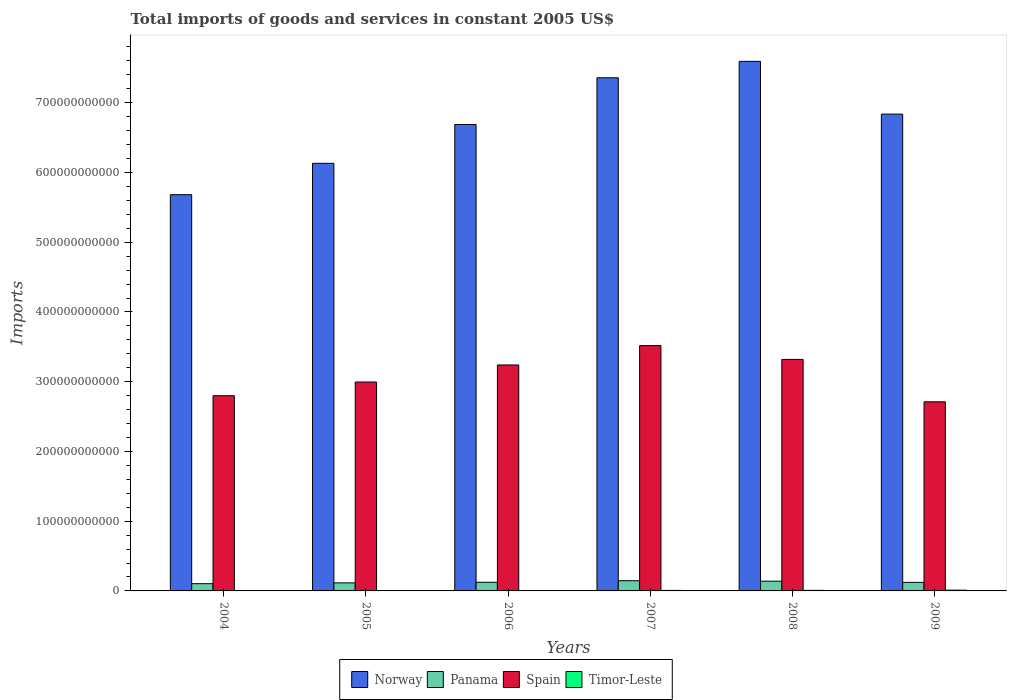How many bars are there on the 4th tick from the right?
Provide a short and direct response. 4. What is the label of the 3rd group of bars from the left?
Your answer should be compact. 2006. In how many cases, is the number of bars for a given year not equal to the number of legend labels?
Keep it short and to the point. 0. What is the total imports of goods and services in Timor-Leste in 2009?
Your answer should be very brief. 1.09e+09. Across all years, what is the maximum total imports of goods and services in Timor-Leste?
Your answer should be very brief. 1.09e+09. Across all years, what is the minimum total imports of goods and services in Norway?
Your response must be concise. 5.68e+11. What is the total total imports of goods and services in Spain in the graph?
Your answer should be very brief. 1.86e+12. What is the difference between the total imports of goods and services in Norway in 2004 and that in 2006?
Your answer should be very brief. -1.01e+11. What is the difference between the total imports of goods and services in Panama in 2006 and the total imports of goods and services in Spain in 2004?
Provide a succinct answer. -2.67e+11. What is the average total imports of goods and services in Timor-Leste per year?
Your answer should be compact. 6.84e+08. In the year 2005, what is the difference between the total imports of goods and services in Panama and total imports of goods and services in Norway?
Keep it short and to the point. -6.02e+11. What is the ratio of the total imports of goods and services in Panama in 2005 to that in 2008?
Your answer should be compact. 0.83. What is the difference between the highest and the second highest total imports of goods and services in Panama?
Your response must be concise. 6.65e+08. What is the difference between the highest and the lowest total imports of goods and services in Norway?
Ensure brevity in your answer.  1.91e+11. Is the sum of the total imports of goods and services in Norway in 2005 and 2008 greater than the maximum total imports of goods and services in Spain across all years?
Your answer should be very brief. Yes. What does the 4th bar from the left in 2006 represents?
Provide a succinct answer. Timor-Leste. What does the 3rd bar from the right in 2009 represents?
Provide a succinct answer. Panama. Are all the bars in the graph horizontal?
Offer a very short reply. No. What is the difference between two consecutive major ticks on the Y-axis?
Your answer should be compact. 1.00e+11. How are the legend labels stacked?
Provide a short and direct response. Horizontal. What is the title of the graph?
Keep it short and to the point. Total imports of goods and services in constant 2005 US$. What is the label or title of the Y-axis?
Offer a very short reply. Imports. What is the Imports in Norway in 2004?
Your answer should be compact. 5.68e+11. What is the Imports in Panama in 2004?
Offer a very short reply. 1.04e+1. What is the Imports of Spain in 2004?
Give a very brief answer. 2.80e+11. What is the Imports of Timor-Leste in 2004?
Offer a very short reply. 5.98e+08. What is the Imports of Norway in 2005?
Provide a short and direct response. 6.13e+11. What is the Imports of Panama in 2005?
Keep it short and to the point. 1.15e+1. What is the Imports of Spain in 2005?
Make the answer very short. 3.00e+11. What is the Imports of Timor-Leste in 2005?
Your answer should be compact. 3.99e+08. What is the Imports of Norway in 2006?
Offer a very short reply. 6.69e+11. What is the Imports in Panama in 2006?
Your response must be concise. 1.24e+1. What is the Imports in Spain in 2006?
Ensure brevity in your answer.  3.24e+11. What is the Imports in Timor-Leste in 2006?
Offer a terse response. 4.84e+08. What is the Imports of Norway in 2007?
Your response must be concise. 7.36e+11. What is the Imports of Panama in 2007?
Your answer should be compact. 1.46e+1. What is the Imports of Spain in 2007?
Offer a terse response. 3.52e+11. What is the Imports in Timor-Leste in 2007?
Provide a succinct answer. 7.21e+08. What is the Imports in Norway in 2008?
Your answer should be very brief. 7.59e+11. What is the Imports in Panama in 2008?
Offer a terse response. 1.40e+1. What is the Imports of Spain in 2008?
Offer a terse response. 3.32e+11. What is the Imports in Timor-Leste in 2008?
Your response must be concise. 8.13e+08. What is the Imports of Norway in 2009?
Your response must be concise. 6.84e+11. What is the Imports in Panama in 2009?
Ensure brevity in your answer.  1.23e+1. What is the Imports of Spain in 2009?
Keep it short and to the point. 2.71e+11. What is the Imports of Timor-Leste in 2009?
Keep it short and to the point. 1.09e+09. Across all years, what is the maximum Imports of Norway?
Provide a short and direct response. 7.59e+11. Across all years, what is the maximum Imports of Panama?
Your answer should be compact. 1.46e+1. Across all years, what is the maximum Imports of Spain?
Offer a terse response. 3.52e+11. Across all years, what is the maximum Imports in Timor-Leste?
Give a very brief answer. 1.09e+09. Across all years, what is the minimum Imports in Norway?
Keep it short and to the point. 5.68e+11. Across all years, what is the minimum Imports in Panama?
Give a very brief answer. 1.04e+1. Across all years, what is the minimum Imports in Spain?
Give a very brief answer. 2.71e+11. Across all years, what is the minimum Imports of Timor-Leste?
Offer a terse response. 3.99e+08. What is the total Imports of Norway in the graph?
Offer a terse response. 4.03e+12. What is the total Imports of Panama in the graph?
Offer a terse response. 7.52e+1. What is the total Imports of Spain in the graph?
Your answer should be very brief. 1.86e+12. What is the total Imports in Timor-Leste in the graph?
Your answer should be compact. 4.10e+09. What is the difference between the Imports in Norway in 2004 and that in 2005?
Offer a very short reply. -4.50e+1. What is the difference between the Imports of Panama in 2004 and that in 2005?
Ensure brevity in your answer.  -1.16e+09. What is the difference between the Imports of Spain in 2004 and that in 2005?
Make the answer very short. -1.97e+1. What is the difference between the Imports in Timor-Leste in 2004 and that in 2005?
Provide a succinct answer. 1.99e+08. What is the difference between the Imports of Norway in 2004 and that in 2006?
Keep it short and to the point. -1.01e+11. What is the difference between the Imports in Panama in 2004 and that in 2006?
Offer a terse response. -2.02e+09. What is the difference between the Imports in Spain in 2004 and that in 2006?
Keep it short and to the point. -4.41e+1. What is the difference between the Imports of Timor-Leste in 2004 and that in 2006?
Provide a short and direct response. 1.14e+08. What is the difference between the Imports of Norway in 2004 and that in 2007?
Provide a succinct answer. -1.68e+11. What is the difference between the Imports in Panama in 2004 and that in 2007?
Your answer should be very brief. -4.25e+09. What is the difference between the Imports in Spain in 2004 and that in 2007?
Your answer should be compact. -7.19e+1. What is the difference between the Imports of Timor-Leste in 2004 and that in 2007?
Your response must be concise. -1.23e+08. What is the difference between the Imports of Norway in 2004 and that in 2008?
Provide a short and direct response. -1.91e+11. What is the difference between the Imports of Panama in 2004 and that in 2008?
Provide a succinct answer. -3.59e+09. What is the difference between the Imports in Spain in 2004 and that in 2008?
Provide a short and direct response. -5.21e+1. What is the difference between the Imports of Timor-Leste in 2004 and that in 2008?
Keep it short and to the point. -2.15e+08. What is the difference between the Imports in Norway in 2004 and that in 2009?
Your answer should be compact. -1.16e+11. What is the difference between the Imports of Panama in 2004 and that in 2009?
Offer a very short reply. -1.88e+09. What is the difference between the Imports in Spain in 2004 and that in 2009?
Your answer should be very brief. 8.70e+09. What is the difference between the Imports in Timor-Leste in 2004 and that in 2009?
Your answer should be very brief. -4.91e+08. What is the difference between the Imports of Norway in 2005 and that in 2006?
Ensure brevity in your answer.  -5.56e+1. What is the difference between the Imports in Panama in 2005 and that in 2006?
Provide a short and direct response. -8.57e+08. What is the difference between the Imports in Spain in 2005 and that in 2006?
Give a very brief answer. -2.45e+1. What is the difference between the Imports of Timor-Leste in 2005 and that in 2006?
Give a very brief answer. -8.50e+07. What is the difference between the Imports in Norway in 2005 and that in 2007?
Your answer should be very brief. -1.23e+11. What is the difference between the Imports in Panama in 2005 and that in 2007?
Provide a short and direct response. -3.09e+09. What is the difference between the Imports of Spain in 2005 and that in 2007?
Your response must be concise. -5.22e+1. What is the difference between the Imports of Timor-Leste in 2005 and that in 2007?
Offer a very short reply. -3.22e+08. What is the difference between the Imports of Norway in 2005 and that in 2008?
Keep it short and to the point. -1.46e+11. What is the difference between the Imports of Panama in 2005 and that in 2008?
Provide a short and direct response. -2.43e+09. What is the difference between the Imports in Spain in 2005 and that in 2008?
Your response must be concise. -3.24e+1. What is the difference between the Imports in Timor-Leste in 2005 and that in 2008?
Provide a short and direct response. -4.14e+08. What is the difference between the Imports in Norway in 2005 and that in 2009?
Offer a terse response. -7.06e+1. What is the difference between the Imports of Panama in 2005 and that in 2009?
Offer a very short reply. -7.20e+08. What is the difference between the Imports of Spain in 2005 and that in 2009?
Your answer should be compact. 2.84e+1. What is the difference between the Imports in Timor-Leste in 2005 and that in 2009?
Your answer should be very brief. -6.90e+08. What is the difference between the Imports in Norway in 2006 and that in 2007?
Keep it short and to the point. -6.70e+1. What is the difference between the Imports in Panama in 2006 and that in 2007?
Your answer should be compact. -2.24e+09. What is the difference between the Imports of Spain in 2006 and that in 2007?
Offer a terse response. -2.77e+1. What is the difference between the Imports in Timor-Leste in 2006 and that in 2007?
Give a very brief answer. -2.37e+08. What is the difference between the Imports in Norway in 2006 and that in 2008?
Provide a short and direct response. -9.06e+1. What is the difference between the Imports in Panama in 2006 and that in 2008?
Your response must be concise. -1.57e+09. What is the difference between the Imports of Spain in 2006 and that in 2008?
Provide a short and direct response. -7.98e+09. What is the difference between the Imports in Timor-Leste in 2006 and that in 2008?
Your response must be concise. -3.29e+08. What is the difference between the Imports of Norway in 2006 and that in 2009?
Your response must be concise. -1.49e+1. What is the difference between the Imports in Panama in 2006 and that in 2009?
Offer a very short reply. 1.37e+08. What is the difference between the Imports in Spain in 2006 and that in 2009?
Offer a terse response. 5.28e+1. What is the difference between the Imports in Timor-Leste in 2006 and that in 2009?
Provide a short and direct response. -6.05e+08. What is the difference between the Imports of Norway in 2007 and that in 2008?
Your answer should be very brief. -2.36e+1. What is the difference between the Imports in Panama in 2007 and that in 2008?
Offer a terse response. 6.65e+08. What is the difference between the Imports in Spain in 2007 and that in 2008?
Offer a terse response. 1.98e+1. What is the difference between the Imports in Timor-Leste in 2007 and that in 2008?
Keep it short and to the point. -9.20e+07. What is the difference between the Imports of Norway in 2007 and that in 2009?
Your answer should be very brief. 5.21e+1. What is the difference between the Imports in Panama in 2007 and that in 2009?
Make the answer very short. 2.37e+09. What is the difference between the Imports of Spain in 2007 and that in 2009?
Your answer should be very brief. 8.06e+1. What is the difference between the Imports in Timor-Leste in 2007 and that in 2009?
Make the answer very short. -3.68e+08. What is the difference between the Imports of Norway in 2008 and that in 2009?
Your response must be concise. 7.56e+1. What is the difference between the Imports of Panama in 2008 and that in 2009?
Keep it short and to the point. 1.71e+09. What is the difference between the Imports of Spain in 2008 and that in 2009?
Make the answer very short. 6.08e+1. What is the difference between the Imports of Timor-Leste in 2008 and that in 2009?
Provide a succinct answer. -2.76e+08. What is the difference between the Imports of Norway in 2004 and the Imports of Panama in 2005?
Keep it short and to the point. 5.57e+11. What is the difference between the Imports in Norway in 2004 and the Imports in Spain in 2005?
Provide a succinct answer. 2.69e+11. What is the difference between the Imports of Norway in 2004 and the Imports of Timor-Leste in 2005?
Keep it short and to the point. 5.68e+11. What is the difference between the Imports of Panama in 2004 and the Imports of Spain in 2005?
Your answer should be very brief. -2.89e+11. What is the difference between the Imports of Panama in 2004 and the Imports of Timor-Leste in 2005?
Ensure brevity in your answer.  9.98e+09. What is the difference between the Imports in Spain in 2004 and the Imports in Timor-Leste in 2005?
Your response must be concise. 2.79e+11. What is the difference between the Imports in Norway in 2004 and the Imports in Panama in 2006?
Keep it short and to the point. 5.56e+11. What is the difference between the Imports in Norway in 2004 and the Imports in Spain in 2006?
Offer a terse response. 2.44e+11. What is the difference between the Imports in Norway in 2004 and the Imports in Timor-Leste in 2006?
Provide a short and direct response. 5.68e+11. What is the difference between the Imports in Panama in 2004 and the Imports in Spain in 2006?
Provide a succinct answer. -3.14e+11. What is the difference between the Imports of Panama in 2004 and the Imports of Timor-Leste in 2006?
Make the answer very short. 9.90e+09. What is the difference between the Imports in Spain in 2004 and the Imports in Timor-Leste in 2006?
Provide a succinct answer. 2.79e+11. What is the difference between the Imports in Norway in 2004 and the Imports in Panama in 2007?
Your answer should be compact. 5.54e+11. What is the difference between the Imports of Norway in 2004 and the Imports of Spain in 2007?
Give a very brief answer. 2.16e+11. What is the difference between the Imports in Norway in 2004 and the Imports in Timor-Leste in 2007?
Your answer should be very brief. 5.67e+11. What is the difference between the Imports in Panama in 2004 and the Imports in Spain in 2007?
Your answer should be compact. -3.41e+11. What is the difference between the Imports of Panama in 2004 and the Imports of Timor-Leste in 2007?
Ensure brevity in your answer.  9.66e+09. What is the difference between the Imports of Spain in 2004 and the Imports of Timor-Leste in 2007?
Offer a terse response. 2.79e+11. What is the difference between the Imports of Norway in 2004 and the Imports of Panama in 2008?
Ensure brevity in your answer.  5.54e+11. What is the difference between the Imports in Norway in 2004 and the Imports in Spain in 2008?
Offer a terse response. 2.36e+11. What is the difference between the Imports of Norway in 2004 and the Imports of Timor-Leste in 2008?
Provide a short and direct response. 5.67e+11. What is the difference between the Imports in Panama in 2004 and the Imports in Spain in 2008?
Keep it short and to the point. -3.22e+11. What is the difference between the Imports in Panama in 2004 and the Imports in Timor-Leste in 2008?
Your answer should be very brief. 9.57e+09. What is the difference between the Imports in Spain in 2004 and the Imports in Timor-Leste in 2008?
Your response must be concise. 2.79e+11. What is the difference between the Imports of Norway in 2004 and the Imports of Panama in 2009?
Your answer should be very brief. 5.56e+11. What is the difference between the Imports in Norway in 2004 and the Imports in Spain in 2009?
Give a very brief answer. 2.97e+11. What is the difference between the Imports in Norway in 2004 and the Imports in Timor-Leste in 2009?
Your answer should be very brief. 5.67e+11. What is the difference between the Imports in Panama in 2004 and the Imports in Spain in 2009?
Offer a terse response. -2.61e+11. What is the difference between the Imports of Panama in 2004 and the Imports of Timor-Leste in 2009?
Offer a terse response. 9.29e+09. What is the difference between the Imports of Spain in 2004 and the Imports of Timor-Leste in 2009?
Give a very brief answer. 2.79e+11. What is the difference between the Imports of Norway in 2005 and the Imports of Panama in 2006?
Ensure brevity in your answer.  6.01e+11. What is the difference between the Imports in Norway in 2005 and the Imports in Spain in 2006?
Ensure brevity in your answer.  2.89e+11. What is the difference between the Imports of Norway in 2005 and the Imports of Timor-Leste in 2006?
Your answer should be very brief. 6.13e+11. What is the difference between the Imports in Panama in 2005 and the Imports in Spain in 2006?
Make the answer very short. -3.12e+11. What is the difference between the Imports of Panama in 2005 and the Imports of Timor-Leste in 2006?
Give a very brief answer. 1.11e+1. What is the difference between the Imports of Spain in 2005 and the Imports of Timor-Leste in 2006?
Provide a short and direct response. 2.99e+11. What is the difference between the Imports in Norway in 2005 and the Imports in Panama in 2007?
Your answer should be very brief. 5.98e+11. What is the difference between the Imports of Norway in 2005 and the Imports of Spain in 2007?
Provide a succinct answer. 2.61e+11. What is the difference between the Imports in Norway in 2005 and the Imports in Timor-Leste in 2007?
Make the answer very short. 6.12e+11. What is the difference between the Imports in Panama in 2005 and the Imports in Spain in 2007?
Offer a terse response. -3.40e+11. What is the difference between the Imports in Panama in 2005 and the Imports in Timor-Leste in 2007?
Keep it short and to the point. 1.08e+1. What is the difference between the Imports of Spain in 2005 and the Imports of Timor-Leste in 2007?
Provide a short and direct response. 2.99e+11. What is the difference between the Imports in Norway in 2005 and the Imports in Panama in 2008?
Ensure brevity in your answer.  5.99e+11. What is the difference between the Imports in Norway in 2005 and the Imports in Spain in 2008?
Ensure brevity in your answer.  2.81e+11. What is the difference between the Imports in Norway in 2005 and the Imports in Timor-Leste in 2008?
Provide a succinct answer. 6.12e+11. What is the difference between the Imports of Panama in 2005 and the Imports of Spain in 2008?
Provide a short and direct response. -3.20e+11. What is the difference between the Imports in Panama in 2005 and the Imports in Timor-Leste in 2008?
Provide a succinct answer. 1.07e+1. What is the difference between the Imports of Spain in 2005 and the Imports of Timor-Leste in 2008?
Provide a short and direct response. 2.99e+11. What is the difference between the Imports in Norway in 2005 and the Imports in Panama in 2009?
Offer a very short reply. 6.01e+11. What is the difference between the Imports of Norway in 2005 and the Imports of Spain in 2009?
Provide a short and direct response. 3.42e+11. What is the difference between the Imports of Norway in 2005 and the Imports of Timor-Leste in 2009?
Ensure brevity in your answer.  6.12e+11. What is the difference between the Imports in Panama in 2005 and the Imports in Spain in 2009?
Offer a very short reply. -2.60e+11. What is the difference between the Imports of Panama in 2005 and the Imports of Timor-Leste in 2009?
Make the answer very short. 1.05e+1. What is the difference between the Imports of Spain in 2005 and the Imports of Timor-Leste in 2009?
Offer a very short reply. 2.98e+11. What is the difference between the Imports in Norway in 2006 and the Imports in Panama in 2007?
Your answer should be compact. 6.54e+11. What is the difference between the Imports in Norway in 2006 and the Imports in Spain in 2007?
Your response must be concise. 3.17e+11. What is the difference between the Imports in Norway in 2006 and the Imports in Timor-Leste in 2007?
Your answer should be compact. 6.68e+11. What is the difference between the Imports of Panama in 2006 and the Imports of Spain in 2007?
Your answer should be very brief. -3.39e+11. What is the difference between the Imports of Panama in 2006 and the Imports of Timor-Leste in 2007?
Your response must be concise. 1.17e+1. What is the difference between the Imports of Spain in 2006 and the Imports of Timor-Leste in 2007?
Provide a succinct answer. 3.23e+11. What is the difference between the Imports of Norway in 2006 and the Imports of Panama in 2008?
Offer a terse response. 6.55e+11. What is the difference between the Imports in Norway in 2006 and the Imports in Spain in 2008?
Give a very brief answer. 3.37e+11. What is the difference between the Imports in Norway in 2006 and the Imports in Timor-Leste in 2008?
Offer a very short reply. 6.68e+11. What is the difference between the Imports of Panama in 2006 and the Imports of Spain in 2008?
Offer a very short reply. -3.20e+11. What is the difference between the Imports of Panama in 2006 and the Imports of Timor-Leste in 2008?
Your response must be concise. 1.16e+1. What is the difference between the Imports of Spain in 2006 and the Imports of Timor-Leste in 2008?
Your response must be concise. 3.23e+11. What is the difference between the Imports in Norway in 2006 and the Imports in Panama in 2009?
Give a very brief answer. 6.57e+11. What is the difference between the Imports of Norway in 2006 and the Imports of Spain in 2009?
Keep it short and to the point. 3.98e+11. What is the difference between the Imports of Norway in 2006 and the Imports of Timor-Leste in 2009?
Your response must be concise. 6.68e+11. What is the difference between the Imports of Panama in 2006 and the Imports of Spain in 2009?
Your answer should be compact. -2.59e+11. What is the difference between the Imports of Panama in 2006 and the Imports of Timor-Leste in 2009?
Make the answer very short. 1.13e+1. What is the difference between the Imports of Spain in 2006 and the Imports of Timor-Leste in 2009?
Make the answer very short. 3.23e+11. What is the difference between the Imports in Norway in 2007 and the Imports in Panama in 2008?
Provide a short and direct response. 7.22e+11. What is the difference between the Imports of Norway in 2007 and the Imports of Spain in 2008?
Provide a short and direct response. 4.04e+11. What is the difference between the Imports in Norway in 2007 and the Imports in Timor-Leste in 2008?
Offer a terse response. 7.35e+11. What is the difference between the Imports in Panama in 2007 and the Imports in Spain in 2008?
Your answer should be compact. -3.17e+11. What is the difference between the Imports of Panama in 2007 and the Imports of Timor-Leste in 2008?
Offer a very short reply. 1.38e+1. What is the difference between the Imports of Spain in 2007 and the Imports of Timor-Leste in 2008?
Provide a succinct answer. 3.51e+11. What is the difference between the Imports in Norway in 2007 and the Imports in Panama in 2009?
Ensure brevity in your answer.  7.24e+11. What is the difference between the Imports of Norway in 2007 and the Imports of Spain in 2009?
Offer a very short reply. 4.65e+11. What is the difference between the Imports in Norway in 2007 and the Imports in Timor-Leste in 2009?
Ensure brevity in your answer.  7.35e+11. What is the difference between the Imports in Panama in 2007 and the Imports in Spain in 2009?
Your answer should be compact. -2.57e+11. What is the difference between the Imports of Panama in 2007 and the Imports of Timor-Leste in 2009?
Keep it short and to the point. 1.35e+1. What is the difference between the Imports in Spain in 2007 and the Imports in Timor-Leste in 2009?
Offer a very short reply. 3.51e+11. What is the difference between the Imports in Norway in 2008 and the Imports in Panama in 2009?
Offer a terse response. 7.47e+11. What is the difference between the Imports of Norway in 2008 and the Imports of Spain in 2009?
Ensure brevity in your answer.  4.88e+11. What is the difference between the Imports in Norway in 2008 and the Imports in Timor-Leste in 2009?
Offer a very short reply. 7.58e+11. What is the difference between the Imports of Panama in 2008 and the Imports of Spain in 2009?
Give a very brief answer. -2.57e+11. What is the difference between the Imports in Panama in 2008 and the Imports in Timor-Leste in 2009?
Give a very brief answer. 1.29e+1. What is the difference between the Imports in Spain in 2008 and the Imports in Timor-Leste in 2009?
Your response must be concise. 3.31e+11. What is the average Imports in Norway per year?
Make the answer very short. 6.71e+11. What is the average Imports of Panama per year?
Keep it short and to the point. 1.25e+1. What is the average Imports in Spain per year?
Make the answer very short. 3.10e+11. What is the average Imports in Timor-Leste per year?
Offer a terse response. 6.84e+08. In the year 2004, what is the difference between the Imports in Norway and Imports in Panama?
Ensure brevity in your answer.  5.58e+11. In the year 2004, what is the difference between the Imports in Norway and Imports in Spain?
Your answer should be compact. 2.88e+11. In the year 2004, what is the difference between the Imports in Norway and Imports in Timor-Leste?
Make the answer very short. 5.68e+11. In the year 2004, what is the difference between the Imports in Panama and Imports in Spain?
Provide a short and direct response. -2.69e+11. In the year 2004, what is the difference between the Imports in Panama and Imports in Timor-Leste?
Offer a very short reply. 9.78e+09. In the year 2004, what is the difference between the Imports of Spain and Imports of Timor-Leste?
Offer a very short reply. 2.79e+11. In the year 2005, what is the difference between the Imports of Norway and Imports of Panama?
Give a very brief answer. 6.02e+11. In the year 2005, what is the difference between the Imports of Norway and Imports of Spain?
Provide a short and direct response. 3.14e+11. In the year 2005, what is the difference between the Imports in Norway and Imports in Timor-Leste?
Make the answer very short. 6.13e+11. In the year 2005, what is the difference between the Imports in Panama and Imports in Spain?
Offer a very short reply. -2.88e+11. In the year 2005, what is the difference between the Imports of Panama and Imports of Timor-Leste?
Provide a short and direct response. 1.11e+1. In the year 2005, what is the difference between the Imports of Spain and Imports of Timor-Leste?
Keep it short and to the point. 2.99e+11. In the year 2006, what is the difference between the Imports of Norway and Imports of Panama?
Make the answer very short. 6.56e+11. In the year 2006, what is the difference between the Imports in Norway and Imports in Spain?
Offer a terse response. 3.45e+11. In the year 2006, what is the difference between the Imports of Norway and Imports of Timor-Leste?
Your answer should be compact. 6.68e+11. In the year 2006, what is the difference between the Imports in Panama and Imports in Spain?
Your answer should be compact. -3.12e+11. In the year 2006, what is the difference between the Imports in Panama and Imports in Timor-Leste?
Keep it short and to the point. 1.19e+1. In the year 2006, what is the difference between the Imports of Spain and Imports of Timor-Leste?
Offer a very short reply. 3.24e+11. In the year 2007, what is the difference between the Imports of Norway and Imports of Panama?
Offer a terse response. 7.21e+11. In the year 2007, what is the difference between the Imports of Norway and Imports of Spain?
Provide a succinct answer. 3.84e+11. In the year 2007, what is the difference between the Imports in Norway and Imports in Timor-Leste?
Keep it short and to the point. 7.35e+11. In the year 2007, what is the difference between the Imports of Panama and Imports of Spain?
Give a very brief answer. -3.37e+11. In the year 2007, what is the difference between the Imports in Panama and Imports in Timor-Leste?
Provide a short and direct response. 1.39e+1. In the year 2007, what is the difference between the Imports in Spain and Imports in Timor-Leste?
Ensure brevity in your answer.  3.51e+11. In the year 2008, what is the difference between the Imports of Norway and Imports of Panama?
Ensure brevity in your answer.  7.45e+11. In the year 2008, what is the difference between the Imports in Norway and Imports in Spain?
Give a very brief answer. 4.27e+11. In the year 2008, what is the difference between the Imports in Norway and Imports in Timor-Leste?
Provide a succinct answer. 7.59e+11. In the year 2008, what is the difference between the Imports in Panama and Imports in Spain?
Your answer should be very brief. -3.18e+11. In the year 2008, what is the difference between the Imports in Panama and Imports in Timor-Leste?
Give a very brief answer. 1.32e+1. In the year 2008, what is the difference between the Imports of Spain and Imports of Timor-Leste?
Your answer should be very brief. 3.31e+11. In the year 2009, what is the difference between the Imports of Norway and Imports of Panama?
Provide a succinct answer. 6.71e+11. In the year 2009, what is the difference between the Imports in Norway and Imports in Spain?
Give a very brief answer. 4.13e+11. In the year 2009, what is the difference between the Imports in Norway and Imports in Timor-Leste?
Provide a short and direct response. 6.83e+11. In the year 2009, what is the difference between the Imports of Panama and Imports of Spain?
Your answer should be very brief. -2.59e+11. In the year 2009, what is the difference between the Imports of Panama and Imports of Timor-Leste?
Offer a terse response. 1.12e+1. In the year 2009, what is the difference between the Imports in Spain and Imports in Timor-Leste?
Make the answer very short. 2.70e+11. What is the ratio of the Imports in Norway in 2004 to that in 2005?
Offer a terse response. 0.93. What is the ratio of the Imports of Panama in 2004 to that in 2005?
Offer a terse response. 0.9. What is the ratio of the Imports in Spain in 2004 to that in 2005?
Your response must be concise. 0.93. What is the ratio of the Imports of Timor-Leste in 2004 to that in 2005?
Give a very brief answer. 1.5. What is the ratio of the Imports in Norway in 2004 to that in 2006?
Your answer should be very brief. 0.85. What is the ratio of the Imports in Panama in 2004 to that in 2006?
Your answer should be very brief. 0.84. What is the ratio of the Imports of Spain in 2004 to that in 2006?
Offer a very short reply. 0.86. What is the ratio of the Imports of Timor-Leste in 2004 to that in 2006?
Your response must be concise. 1.24. What is the ratio of the Imports of Norway in 2004 to that in 2007?
Your answer should be compact. 0.77. What is the ratio of the Imports in Panama in 2004 to that in 2007?
Your answer should be compact. 0.71. What is the ratio of the Imports of Spain in 2004 to that in 2007?
Offer a terse response. 0.8. What is the ratio of the Imports of Timor-Leste in 2004 to that in 2007?
Provide a succinct answer. 0.83. What is the ratio of the Imports in Norway in 2004 to that in 2008?
Offer a terse response. 0.75. What is the ratio of the Imports in Panama in 2004 to that in 2008?
Provide a short and direct response. 0.74. What is the ratio of the Imports in Spain in 2004 to that in 2008?
Provide a short and direct response. 0.84. What is the ratio of the Imports in Timor-Leste in 2004 to that in 2008?
Offer a very short reply. 0.74. What is the ratio of the Imports of Norway in 2004 to that in 2009?
Your answer should be compact. 0.83. What is the ratio of the Imports of Panama in 2004 to that in 2009?
Keep it short and to the point. 0.85. What is the ratio of the Imports in Spain in 2004 to that in 2009?
Offer a very short reply. 1.03. What is the ratio of the Imports of Timor-Leste in 2004 to that in 2009?
Keep it short and to the point. 0.55. What is the ratio of the Imports in Norway in 2005 to that in 2006?
Make the answer very short. 0.92. What is the ratio of the Imports in Panama in 2005 to that in 2006?
Provide a succinct answer. 0.93. What is the ratio of the Imports of Spain in 2005 to that in 2006?
Ensure brevity in your answer.  0.92. What is the ratio of the Imports in Timor-Leste in 2005 to that in 2006?
Give a very brief answer. 0.82. What is the ratio of the Imports of Norway in 2005 to that in 2007?
Your response must be concise. 0.83. What is the ratio of the Imports of Panama in 2005 to that in 2007?
Keep it short and to the point. 0.79. What is the ratio of the Imports of Spain in 2005 to that in 2007?
Your response must be concise. 0.85. What is the ratio of the Imports of Timor-Leste in 2005 to that in 2007?
Your response must be concise. 0.55. What is the ratio of the Imports of Norway in 2005 to that in 2008?
Offer a terse response. 0.81. What is the ratio of the Imports of Panama in 2005 to that in 2008?
Offer a very short reply. 0.83. What is the ratio of the Imports in Spain in 2005 to that in 2008?
Give a very brief answer. 0.9. What is the ratio of the Imports of Timor-Leste in 2005 to that in 2008?
Provide a succinct answer. 0.49. What is the ratio of the Imports of Norway in 2005 to that in 2009?
Your answer should be compact. 0.9. What is the ratio of the Imports in Panama in 2005 to that in 2009?
Ensure brevity in your answer.  0.94. What is the ratio of the Imports of Spain in 2005 to that in 2009?
Give a very brief answer. 1.1. What is the ratio of the Imports of Timor-Leste in 2005 to that in 2009?
Offer a terse response. 0.37. What is the ratio of the Imports of Norway in 2006 to that in 2007?
Provide a short and direct response. 0.91. What is the ratio of the Imports of Panama in 2006 to that in 2007?
Your answer should be very brief. 0.85. What is the ratio of the Imports of Spain in 2006 to that in 2007?
Offer a terse response. 0.92. What is the ratio of the Imports of Timor-Leste in 2006 to that in 2007?
Keep it short and to the point. 0.67. What is the ratio of the Imports of Norway in 2006 to that in 2008?
Make the answer very short. 0.88. What is the ratio of the Imports of Panama in 2006 to that in 2008?
Offer a very short reply. 0.89. What is the ratio of the Imports of Spain in 2006 to that in 2008?
Keep it short and to the point. 0.98. What is the ratio of the Imports of Timor-Leste in 2006 to that in 2008?
Offer a very short reply. 0.6. What is the ratio of the Imports in Norway in 2006 to that in 2009?
Your answer should be very brief. 0.98. What is the ratio of the Imports of Panama in 2006 to that in 2009?
Provide a short and direct response. 1.01. What is the ratio of the Imports in Spain in 2006 to that in 2009?
Keep it short and to the point. 1.19. What is the ratio of the Imports of Timor-Leste in 2006 to that in 2009?
Offer a terse response. 0.44. What is the ratio of the Imports of Panama in 2007 to that in 2008?
Your response must be concise. 1.05. What is the ratio of the Imports of Spain in 2007 to that in 2008?
Give a very brief answer. 1.06. What is the ratio of the Imports of Timor-Leste in 2007 to that in 2008?
Offer a terse response. 0.89. What is the ratio of the Imports in Norway in 2007 to that in 2009?
Ensure brevity in your answer.  1.08. What is the ratio of the Imports of Panama in 2007 to that in 2009?
Give a very brief answer. 1.19. What is the ratio of the Imports of Spain in 2007 to that in 2009?
Offer a very short reply. 1.3. What is the ratio of the Imports of Timor-Leste in 2007 to that in 2009?
Your answer should be compact. 0.66. What is the ratio of the Imports in Norway in 2008 to that in 2009?
Your response must be concise. 1.11. What is the ratio of the Imports in Panama in 2008 to that in 2009?
Offer a very short reply. 1.14. What is the ratio of the Imports in Spain in 2008 to that in 2009?
Provide a short and direct response. 1.22. What is the ratio of the Imports of Timor-Leste in 2008 to that in 2009?
Ensure brevity in your answer.  0.75. What is the difference between the highest and the second highest Imports in Norway?
Offer a very short reply. 2.36e+1. What is the difference between the highest and the second highest Imports in Panama?
Provide a succinct answer. 6.65e+08. What is the difference between the highest and the second highest Imports in Spain?
Give a very brief answer. 1.98e+1. What is the difference between the highest and the second highest Imports of Timor-Leste?
Your answer should be very brief. 2.76e+08. What is the difference between the highest and the lowest Imports in Norway?
Your response must be concise. 1.91e+11. What is the difference between the highest and the lowest Imports of Panama?
Give a very brief answer. 4.25e+09. What is the difference between the highest and the lowest Imports in Spain?
Offer a terse response. 8.06e+1. What is the difference between the highest and the lowest Imports in Timor-Leste?
Give a very brief answer. 6.90e+08. 